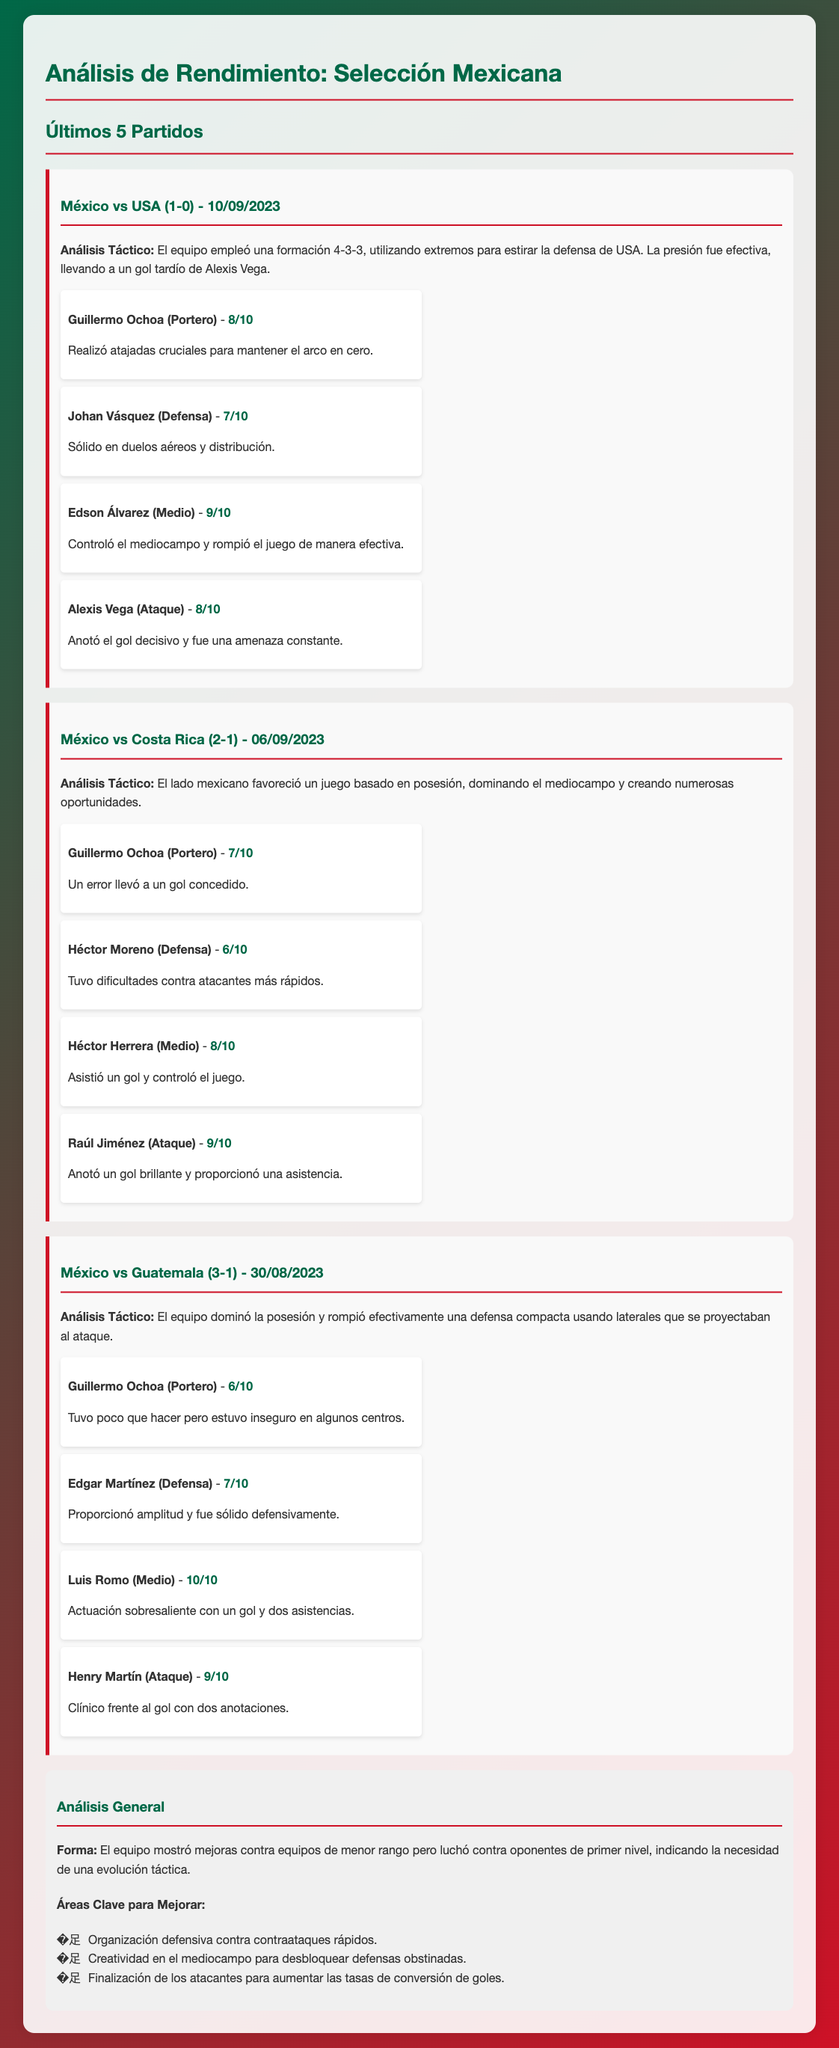What was the final score of the match against USA? The score of the match was reported in the document as 1-0 in favor of Mexico.
Answer: 1-0 Who scored the decisive goal in the match against USA? The player who scored the decisive goal is mentioned in the document as Alexis Vega.
Answer: Alexis Vega What formation did the Mexican team use against Costa Rica? The document states that Mexico favored a formation based on possession against Costa Rica, but does not specify a formation; however, it mentions controlling the midfield.
Answer: 4-3-3 What was Luis Romo's rating in the match against Guatemala? The document provides Luis Romo's performance rating as 10/10 in the match against Guatemala.
Answer: 10/10 What is one area identified for improvement in the team? The document lists several areas for improvement, including "organización defensiva contra contraataques rápidos."
Answer: Organización defensiva How did Guillermo Ochoa perform against Guatemala? The document states Guillermo Ochoa's rating against Guatemala was 6/10, indicating he was "inseguro en algunos centros."
Answer: 6/10 What tactic did Mexico employ against Guatemala to break through defense? The document mentions the use of "laterales que se proyectaban al ataque" to effectively break through a compact defense.
Answer: Laterales What date was the match against Costa Rica? The document lists the match against Costa Rica took place on 06/09/2023.
Answer: 06/09/2023 